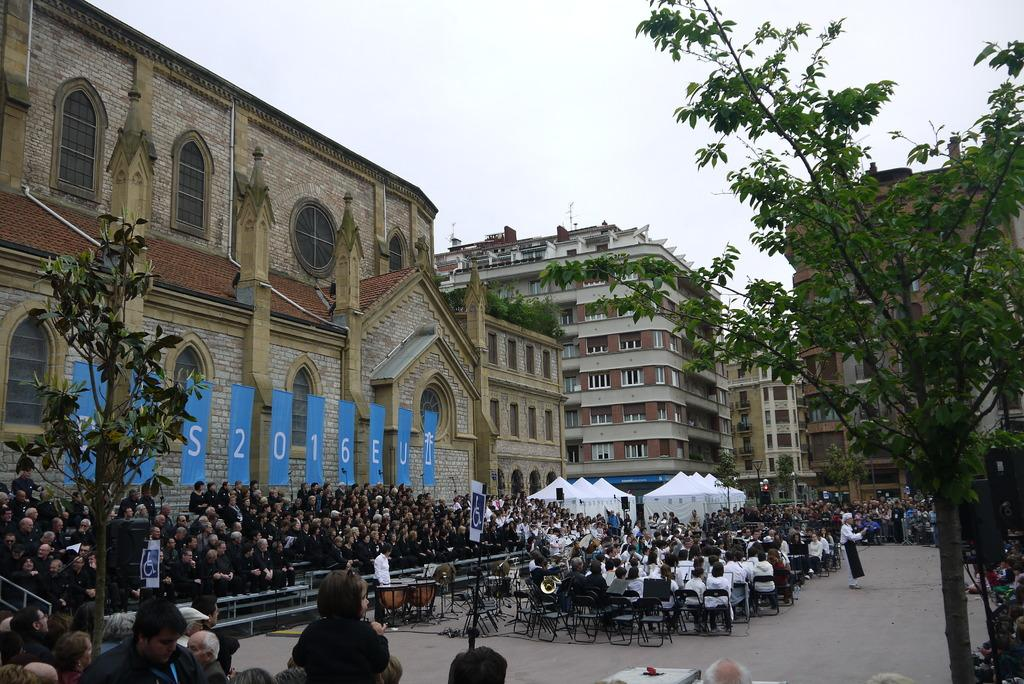What are the people in the image doing? There is a group of people sitting in chairs in the image. What type of structure can be seen in the image? There is a building with windows in the image. What type of vegetation is present in the image? There are plants and trees in the image. What type of pathway is visible in the image? There is a road in the image. Can you describe the person standing in the image? There is a person standing in the image. What is visible in the sky in the image? The sky is visible in the image. What type of growth can be seen on the person standing in the image? There is no growth visible on the person standing in the image. What type of station is present in the image? There is no station present in the image. 